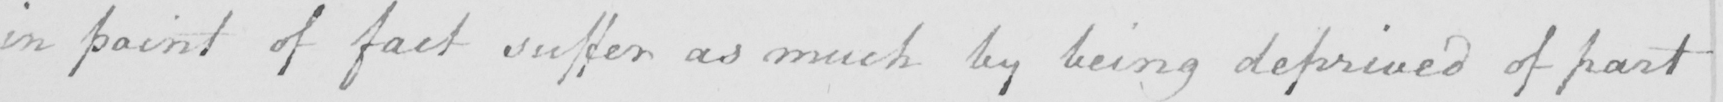What is written in this line of handwriting? in point of fact suffer as much by being deprived of part 